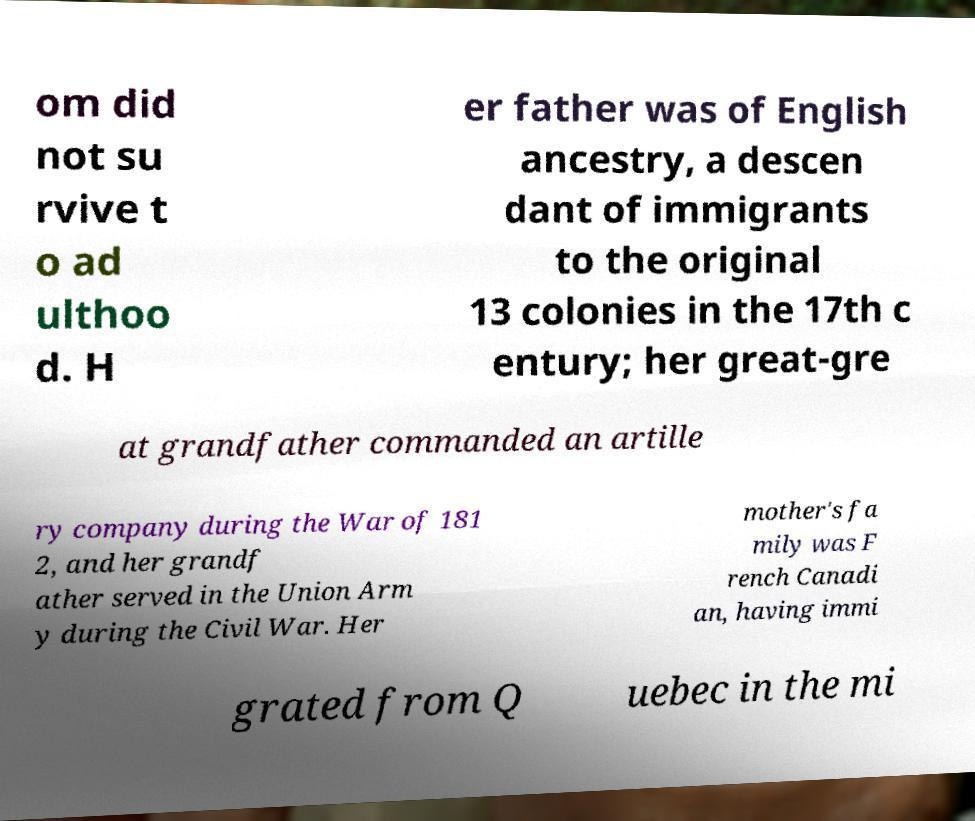Can you accurately transcribe the text from the provided image for me? om did not su rvive t o ad ulthoo d. H er father was of English ancestry, a descen dant of immigrants to the original 13 colonies in the 17th c entury; her great-gre at grandfather commanded an artille ry company during the War of 181 2, and her grandf ather served in the Union Arm y during the Civil War. Her mother's fa mily was F rench Canadi an, having immi grated from Q uebec in the mi 